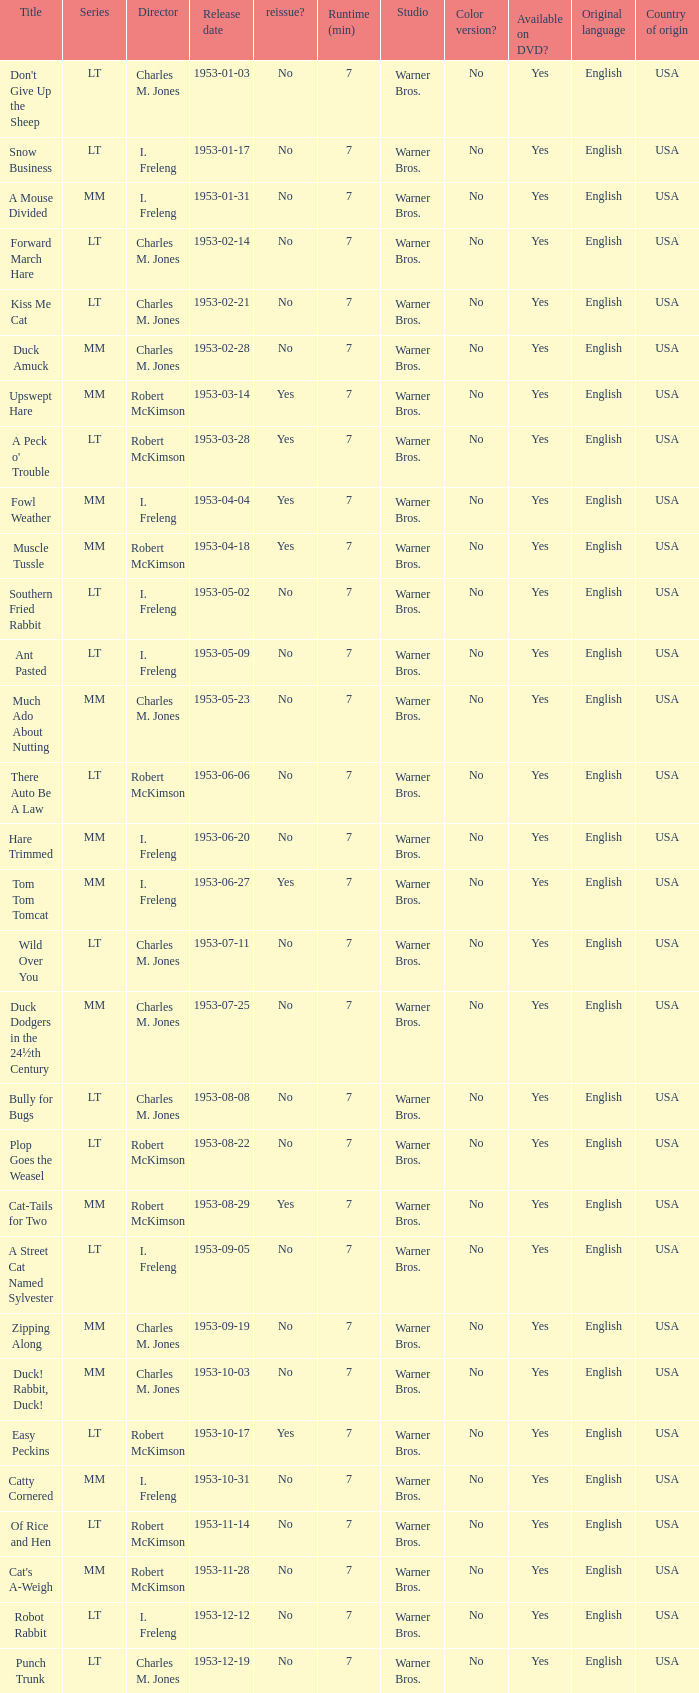What's the series of Kiss Me Cat? LT. 